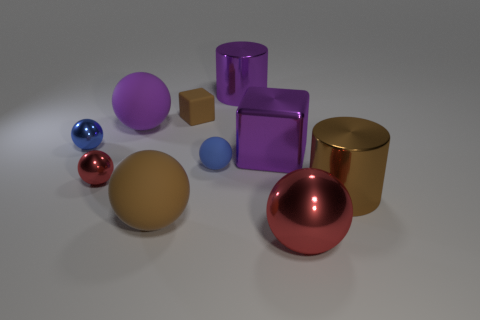Does the metallic cylinder that is behind the brown block have the same size as the matte cube? The metallic cylinder appears to be slightly taller and has a different diameter compared to the matte cube. They are not the same size; the cube has equal dimensions on all sides, while the cylinder's height and diameter are not equal to the cube's dimensions. 